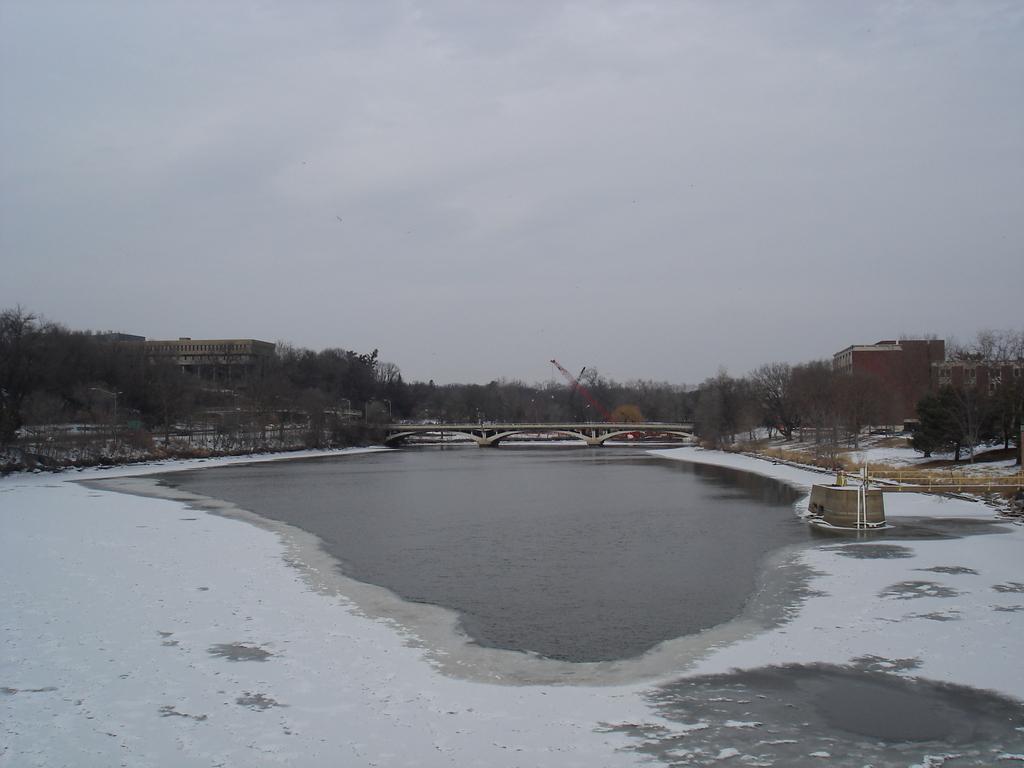Describe this image in one or two sentences. There is water, on which there is snow. In the background, there is a bridge built on the water, there are trees, buildings and there are clouds in the sky. 